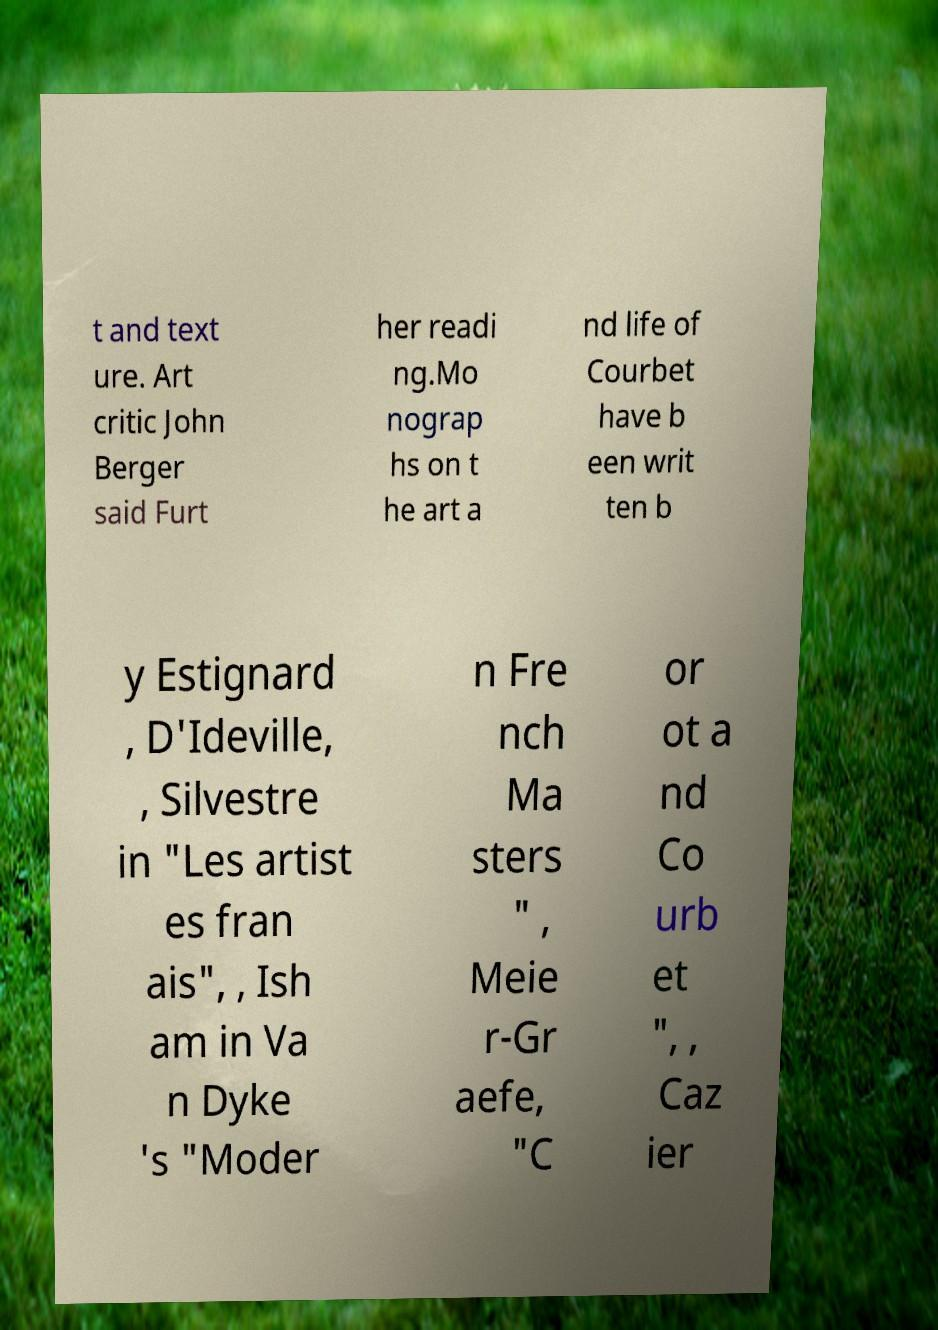I need the written content from this picture converted into text. Can you do that? t and text ure. Art critic John Berger said Furt her readi ng.Mo nograp hs on t he art a nd life of Courbet have b een writ ten b y Estignard , D'Ideville, , Silvestre in "Les artist es fran ais", , Ish am in Va n Dyke 's "Moder n Fre nch Ma sters " , Meie r-Gr aefe, "C or ot a nd Co urb et ", , Caz ier 